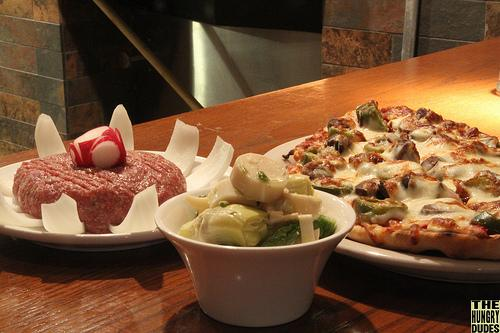Comment on the color and material of the dish containing artichoke salad. The dish containing artichoke salad is made of ceramic and is white in color. Can you identify the main elements present in the image and their placement? The image shows a wooden table laden with a plate of food, a raw ground beef patty, radishes as garnish, a white bowl containing artichoke salad, a small vegetable pizza on a white plate, and a decorative marble brick wall in the background. Mention three types of food present on the wooden table. Three types of food present on the wooden table are a raw ground beef patty, a vegetable pizza, and an artichoke salad in a white bowl. Describe the type, position, and any notable features of the table where the food is placed. The table is made of varnished golden oak wood and is positioned beneath all the food items, with a watermark of the hungry dudes at the bottom-right corner. What are some objects casting shadows in the image and where are these shadows located? The bowl casts a shadow beneath it, and the shadow of the plate is on the table beside it. How many toppings can be seen on the pizza and describe them briefly. There are five different toppings on the pizza: mushroom, cheese, peppers, and two additional unspecified toppings. What kind of garnish is used in the image and where is it located? Radish is used as a garnish and it is placed on top of the raw ground beef patty, which is on the wooden table. What type of toppings are on the pizza and describe the pizza's placement? The pizza has mushroom, cheese, and peppers as toppings and it is positioned on a white plate, which is placed on the wooden table. Please enumerate the different elements under the category of food in this image. Raw ground beef patty, sliced radishes, onion petals, artichoke salad, vegetable pizza, and mixed green vegetables in a single serve dish. Count the food items present on the table and provide a brief list. There are six food items on the table: 1) raw ground beef patty, 2) vegetable pizza, 3) artichoke salad, 4) sliced radishes, 5) onion petals, 6) mixed green vegetables in a single serve dish. 